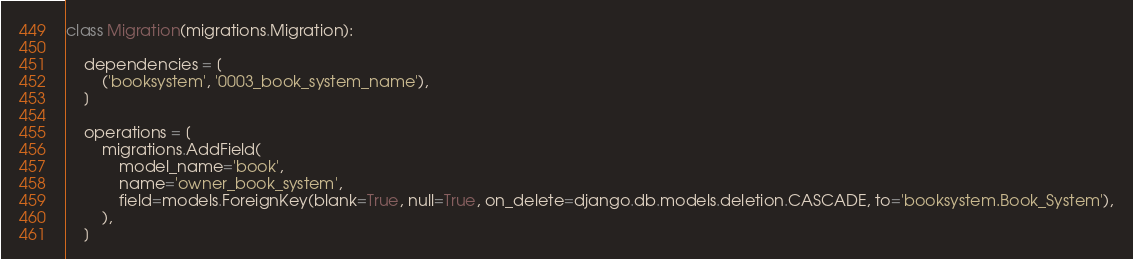<code> <loc_0><loc_0><loc_500><loc_500><_Python_>

class Migration(migrations.Migration):

    dependencies = [
        ('booksystem', '0003_book_system_name'),
    ]

    operations = [
        migrations.AddField(
            model_name='book',
            name='owner_book_system',
            field=models.ForeignKey(blank=True, null=True, on_delete=django.db.models.deletion.CASCADE, to='booksystem.Book_System'),
        ),
    ]
</code> 